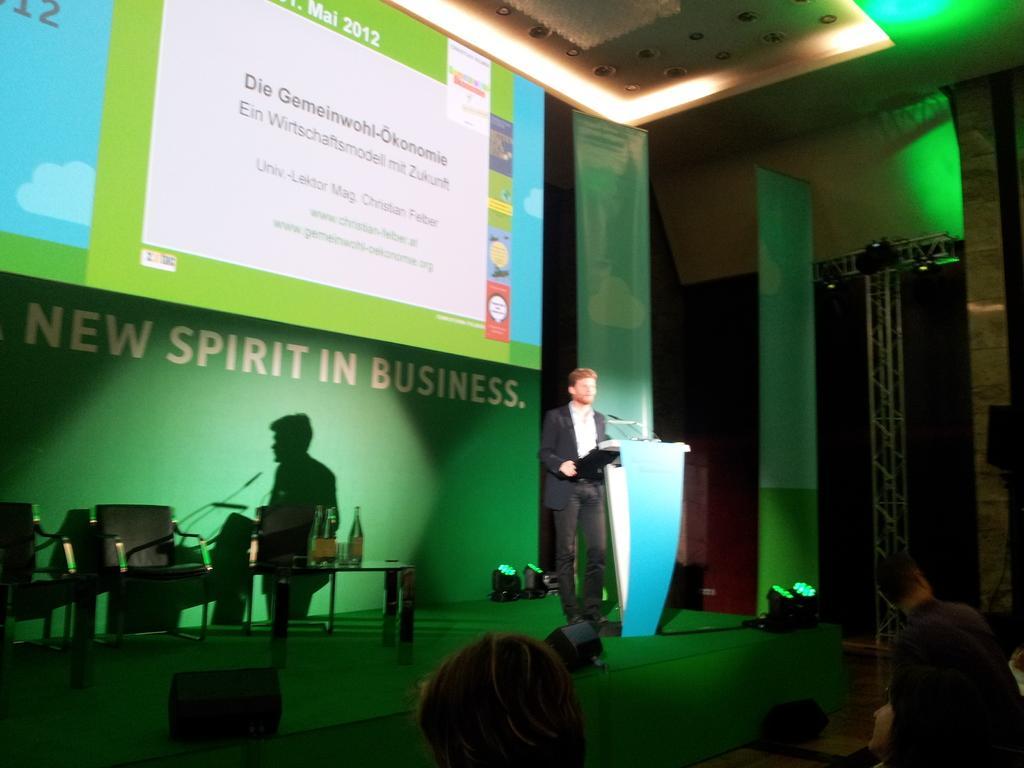Please provide a concise description of this image. In this image we can see a person standing on the stage beside a speaker stand containing a mic on it. We can also see chairs, bottles on a table, lights, the metal frame, a display screen with some text on it, some banners and a roof with some ceiling lights. On the bottom of the image we can see some people. 